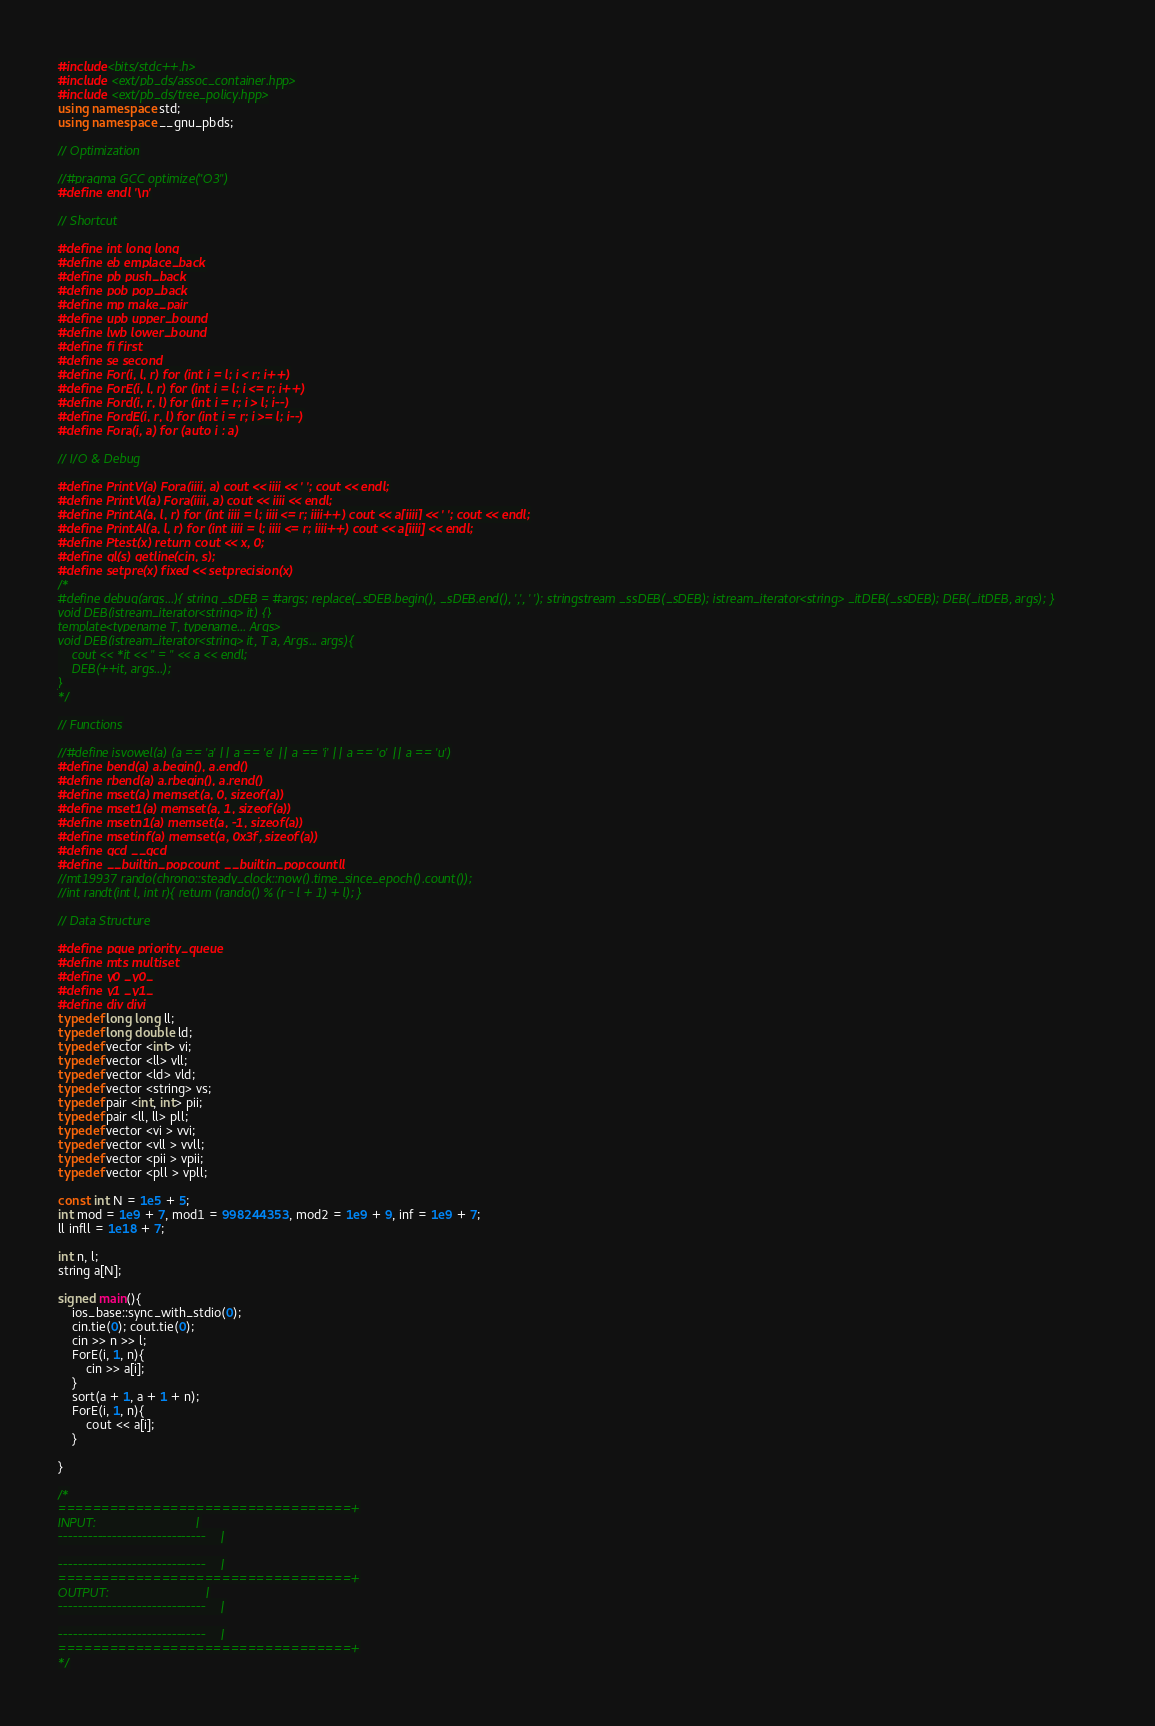Convert code to text. <code><loc_0><loc_0><loc_500><loc_500><_C++_>#include<bits/stdc++.h>
#include <ext/pb_ds/assoc_container.hpp>
#include <ext/pb_ds/tree_policy.hpp>
using namespace std;
using namespace __gnu_pbds;

// Optimization

//#pragma GCC optimize("O3")
#define endl '\n'

// Shortcut

#define int long long
#define eb emplace_back
#define pb push_back
#define pob pop_back
#define mp make_pair
#define upb upper_bound
#define lwb lower_bound
#define fi first
#define se second
#define For(i, l, r) for (int i = l; i < r; i++)
#define ForE(i, l, r) for (int i = l; i <= r; i++)
#define Ford(i, r, l) for (int i = r; i > l; i--)
#define FordE(i, r, l) for (int i = r; i >= l; i--)
#define Fora(i, a) for (auto i : a)

// I/O & Debug

#define PrintV(a) Fora(iiii, a) cout << iiii << ' '; cout << endl;
#define PrintVl(a) Fora(iiii, a) cout << iiii << endl;
#define PrintA(a, l, r) for (int iiii = l; iiii <= r; iiii++) cout << a[iiii] << ' '; cout << endl;
#define PrintAl(a, l, r) for (int iiii = l; iiii <= r; iiii++) cout << a[iiii] << endl;
#define Ptest(x) return cout << x, 0;
#define gl(s) getline(cin, s);
#define setpre(x) fixed << setprecision(x)
/*
#define debug(args...){ string _sDEB = #args; replace(_sDEB.begin(), _sDEB.end(), ',', ' '); stringstream _ssDEB(_sDEB); istream_iterator<string> _itDEB(_ssDEB); DEB(_itDEB, args); }
void DEB(istream_iterator<string> it) {}
template<typename T, typename... Args>
void DEB(istream_iterator<string> it, T a, Args... args){
    cout << *it << " = " << a << endl;
    DEB(++it, args...);
}
*/

// Functions

//#define isvowel(a) (a == 'a' || a == 'e' || a == 'i' || a == 'o' || a == 'u')
#define bend(a) a.begin(), a.end()
#define rbend(a) a.rbegin(), a.rend()
#define mset(a) memset(a, 0, sizeof(a))
#define mset1(a) memset(a, 1, sizeof(a))
#define msetn1(a) memset(a, -1, sizeof(a))
#define msetinf(a) memset(a, 0x3f, sizeof(a))
#define gcd __gcd
#define __builtin_popcount __builtin_popcountll
//mt19937 rando(chrono::steady_clock::now().time_since_epoch().count());
//int randt(int l, int r){ return (rando() % (r - l + 1) + l); }

// Data Structure

#define pque priority_queue
#define mts multiset
#define y0 _y0_
#define y1 _y1_
#define div divi
typedef long long ll;
typedef long double ld;
typedef vector <int> vi;
typedef vector <ll> vll;
typedef vector <ld> vld;
typedef vector <string> vs;
typedef pair <int, int> pii;
typedef pair <ll, ll> pll;
typedef vector <vi > vvi;
typedef vector <vll > vvll;
typedef vector <pii > vpii;
typedef vector <pll > vpll;

const int N = 1e5 + 5;
int mod = 1e9 + 7, mod1 = 998244353, mod2 = 1e9 + 9, inf = 1e9 + 7;
ll infll = 1e18 + 7;

int n, l;
string a[N];

signed main(){
    ios_base::sync_with_stdio(0);
    cin.tie(0); cout.tie(0);
    cin >> n >> l;
    ForE(i, 1, n){
        cin >> a[i];
    }
    sort(a + 1, a + 1 + n);
    ForE(i, 1, n){
        cout << a[i];
    }
    
}

/*
==================================+
INPUT:                            |
------------------------------    |

------------------------------    |
==================================+
OUTPUT:                           |
------------------------------    |

------------------------------    |
==================================+
*/</code> 